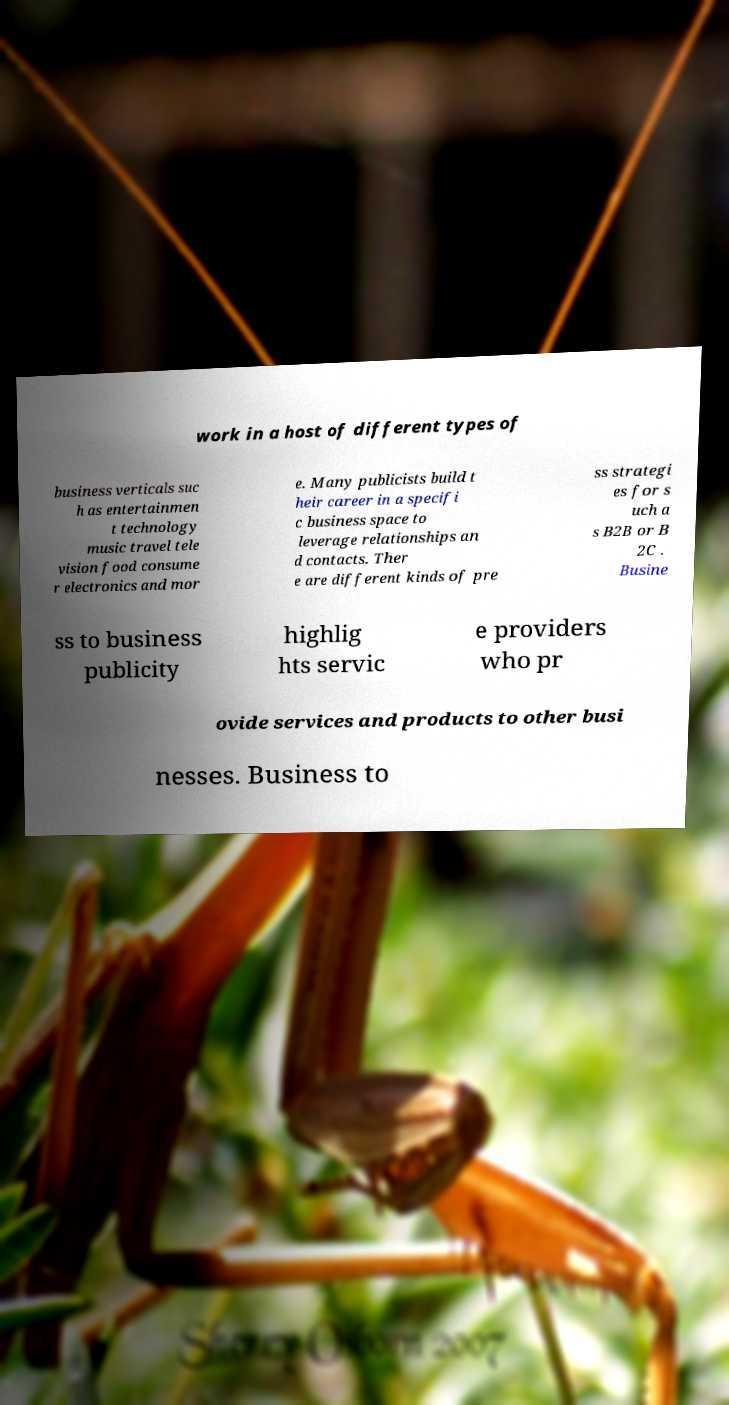Could you assist in decoding the text presented in this image and type it out clearly? work in a host of different types of business verticals suc h as entertainmen t technology music travel tele vision food consume r electronics and mor e. Many publicists build t heir career in a specifi c business space to leverage relationships an d contacts. Ther e are different kinds of pre ss strategi es for s uch a s B2B or B 2C . Busine ss to business publicity highlig hts servic e providers who pr ovide services and products to other busi nesses. Business to 